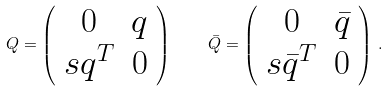Convert formula to latex. <formula><loc_0><loc_0><loc_500><loc_500>Q = \left ( \begin{array} { c c } { 0 } & { q } \\ { { s q ^ { T } } } & { 0 } \end{array} \right ) \quad \bar { Q } = \left ( \begin{array} { c c } { 0 } & { { \bar { q } } } \\ { { s \bar { q } ^ { T } } } & { 0 } \end{array} \right ) \, .</formula> 